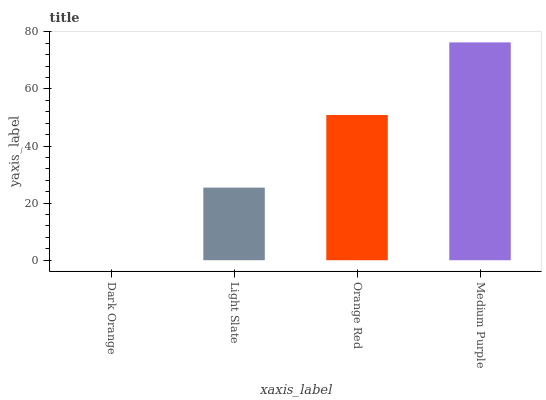Is Dark Orange the minimum?
Answer yes or no. Yes. Is Medium Purple the maximum?
Answer yes or no. Yes. Is Light Slate the minimum?
Answer yes or no. No. Is Light Slate the maximum?
Answer yes or no. No. Is Light Slate greater than Dark Orange?
Answer yes or no. Yes. Is Dark Orange less than Light Slate?
Answer yes or no. Yes. Is Dark Orange greater than Light Slate?
Answer yes or no. No. Is Light Slate less than Dark Orange?
Answer yes or no. No. Is Orange Red the high median?
Answer yes or no. Yes. Is Light Slate the low median?
Answer yes or no. Yes. Is Medium Purple the high median?
Answer yes or no. No. Is Orange Red the low median?
Answer yes or no. No. 